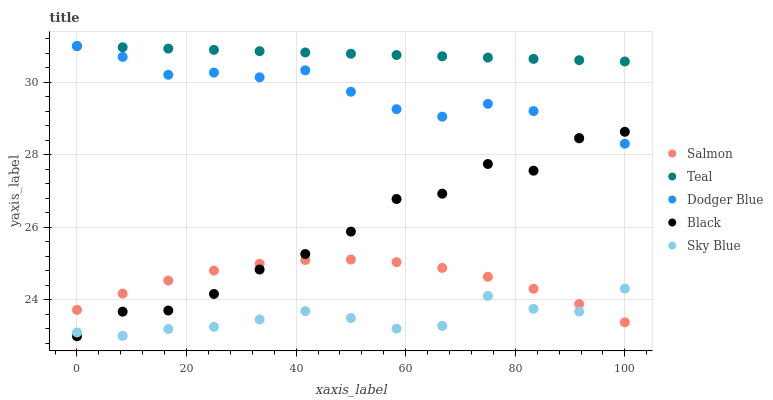Does Sky Blue have the minimum area under the curve?
Answer yes or no. Yes. Does Teal have the maximum area under the curve?
Answer yes or no. Yes. Does Salmon have the minimum area under the curve?
Answer yes or no. No. Does Salmon have the maximum area under the curve?
Answer yes or no. No. Is Teal the smoothest?
Answer yes or no. Yes. Is Black the roughest?
Answer yes or no. Yes. Is Sky Blue the smoothest?
Answer yes or no. No. Is Sky Blue the roughest?
Answer yes or no. No. Does Black have the lowest value?
Answer yes or no. Yes. Does Sky Blue have the lowest value?
Answer yes or no. No. Does Teal have the highest value?
Answer yes or no. Yes. Does Salmon have the highest value?
Answer yes or no. No. Is Sky Blue less than Teal?
Answer yes or no. Yes. Is Teal greater than Salmon?
Answer yes or no. Yes. Does Sky Blue intersect Black?
Answer yes or no. Yes. Is Sky Blue less than Black?
Answer yes or no. No. Is Sky Blue greater than Black?
Answer yes or no. No. Does Sky Blue intersect Teal?
Answer yes or no. No. 